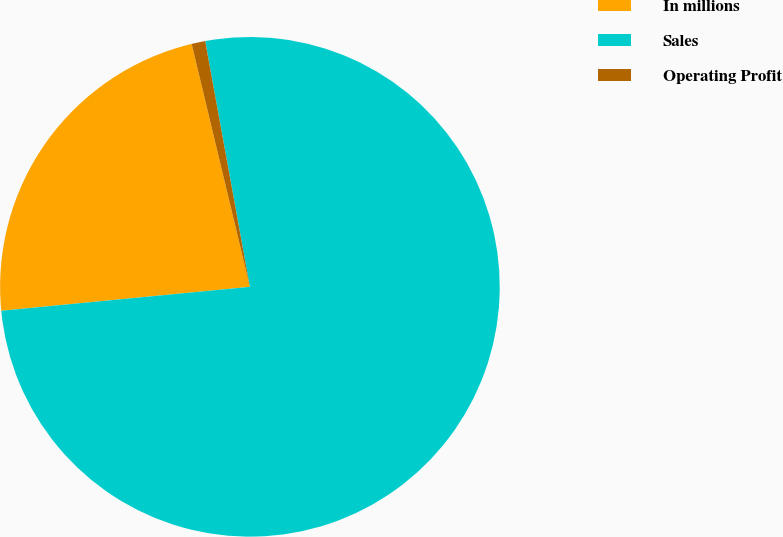Convert chart. <chart><loc_0><loc_0><loc_500><loc_500><pie_chart><fcel>In millions<fcel>Sales<fcel>Operating Profit<nl><fcel>22.78%<fcel>76.33%<fcel>0.88%<nl></chart> 